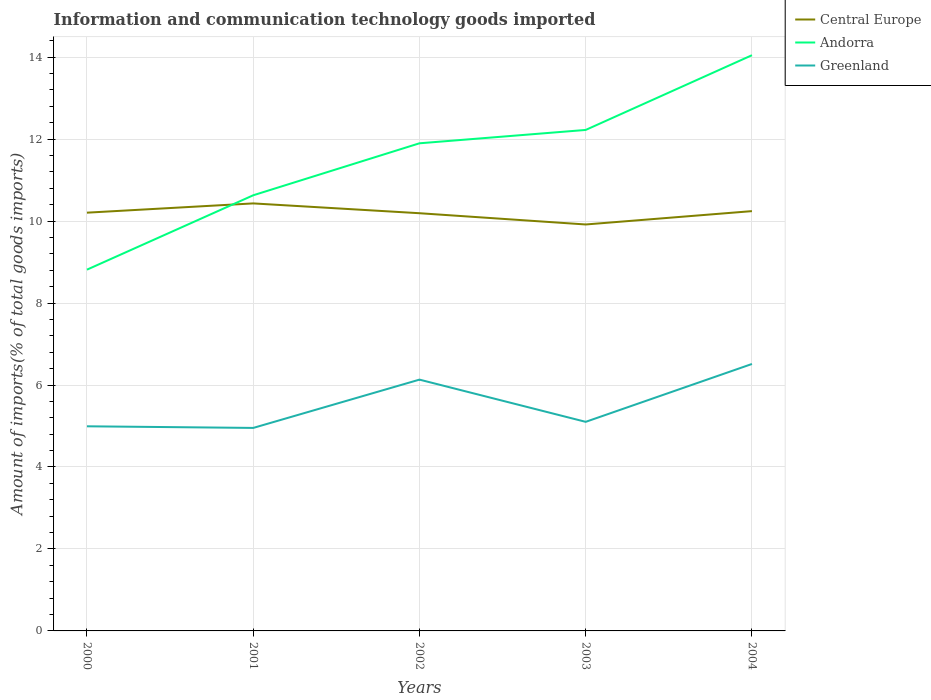Across all years, what is the maximum amount of goods imported in Greenland?
Keep it short and to the point. 4.95. What is the total amount of goods imported in Andorra in the graph?
Offer a terse response. -1.27. What is the difference between the highest and the second highest amount of goods imported in Andorra?
Offer a terse response. 5.23. What is the difference between the highest and the lowest amount of goods imported in Central Europe?
Offer a terse response. 3. Is the amount of goods imported in Andorra strictly greater than the amount of goods imported in Central Europe over the years?
Make the answer very short. No. Are the values on the major ticks of Y-axis written in scientific E-notation?
Ensure brevity in your answer.  No. Does the graph contain any zero values?
Your answer should be compact. No. Does the graph contain grids?
Keep it short and to the point. Yes. How many legend labels are there?
Provide a succinct answer. 3. How are the legend labels stacked?
Your response must be concise. Vertical. What is the title of the graph?
Give a very brief answer. Information and communication technology goods imported. What is the label or title of the X-axis?
Give a very brief answer. Years. What is the label or title of the Y-axis?
Make the answer very short. Amount of imports(% of total goods imports). What is the Amount of imports(% of total goods imports) in Central Europe in 2000?
Your answer should be very brief. 10.2. What is the Amount of imports(% of total goods imports) in Andorra in 2000?
Keep it short and to the point. 8.81. What is the Amount of imports(% of total goods imports) in Greenland in 2000?
Ensure brevity in your answer.  4.99. What is the Amount of imports(% of total goods imports) in Central Europe in 2001?
Offer a very short reply. 10.43. What is the Amount of imports(% of total goods imports) in Andorra in 2001?
Give a very brief answer. 10.63. What is the Amount of imports(% of total goods imports) of Greenland in 2001?
Provide a succinct answer. 4.95. What is the Amount of imports(% of total goods imports) in Central Europe in 2002?
Offer a very short reply. 10.19. What is the Amount of imports(% of total goods imports) in Andorra in 2002?
Ensure brevity in your answer.  11.9. What is the Amount of imports(% of total goods imports) in Greenland in 2002?
Provide a succinct answer. 6.13. What is the Amount of imports(% of total goods imports) of Central Europe in 2003?
Ensure brevity in your answer.  9.92. What is the Amount of imports(% of total goods imports) of Andorra in 2003?
Your answer should be compact. 12.22. What is the Amount of imports(% of total goods imports) in Greenland in 2003?
Offer a very short reply. 5.1. What is the Amount of imports(% of total goods imports) in Central Europe in 2004?
Your answer should be compact. 10.24. What is the Amount of imports(% of total goods imports) in Andorra in 2004?
Your answer should be compact. 14.05. What is the Amount of imports(% of total goods imports) in Greenland in 2004?
Make the answer very short. 6.51. Across all years, what is the maximum Amount of imports(% of total goods imports) in Central Europe?
Make the answer very short. 10.43. Across all years, what is the maximum Amount of imports(% of total goods imports) in Andorra?
Ensure brevity in your answer.  14.05. Across all years, what is the maximum Amount of imports(% of total goods imports) in Greenland?
Keep it short and to the point. 6.51. Across all years, what is the minimum Amount of imports(% of total goods imports) in Central Europe?
Offer a terse response. 9.92. Across all years, what is the minimum Amount of imports(% of total goods imports) of Andorra?
Provide a succinct answer. 8.81. Across all years, what is the minimum Amount of imports(% of total goods imports) of Greenland?
Provide a short and direct response. 4.95. What is the total Amount of imports(% of total goods imports) of Central Europe in the graph?
Give a very brief answer. 50.99. What is the total Amount of imports(% of total goods imports) in Andorra in the graph?
Make the answer very short. 57.61. What is the total Amount of imports(% of total goods imports) in Greenland in the graph?
Offer a terse response. 27.69. What is the difference between the Amount of imports(% of total goods imports) in Central Europe in 2000 and that in 2001?
Your answer should be very brief. -0.23. What is the difference between the Amount of imports(% of total goods imports) in Andorra in 2000 and that in 2001?
Your response must be concise. -1.81. What is the difference between the Amount of imports(% of total goods imports) in Greenland in 2000 and that in 2001?
Provide a short and direct response. 0.04. What is the difference between the Amount of imports(% of total goods imports) of Central Europe in 2000 and that in 2002?
Ensure brevity in your answer.  0.01. What is the difference between the Amount of imports(% of total goods imports) in Andorra in 2000 and that in 2002?
Your answer should be compact. -3.08. What is the difference between the Amount of imports(% of total goods imports) of Greenland in 2000 and that in 2002?
Give a very brief answer. -1.14. What is the difference between the Amount of imports(% of total goods imports) of Central Europe in 2000 and that in 2003?
Your answer should be compact. 0.29. What is the difference between the Amount of imports(% of total goods imports) of Andorra in 2000 and that in 2003?
Ensure brevity in your answer.  -3.41. What is the difference between the Amount of imports(% of total goods imports) of Greenland in 2000 and that in 2003?
Your answer should be very brief. -0.11. What is the difference between the Amount of imports(% of total goods imports) in Central Europe in 2000 and that in 2004?
Offer a terse response. -0.04. What is the difference between the Amount of imports(% of total goods imports) of Andorra in 2000 and that in 2004?
Provide a short and direct response. -5.23. What is the difference between the Amount of imports(% of total goods imports) of Greenland in 2000 and that in 2004?
Your answer should be compact. -1.52. What is the difference between the Amount of imports(% of total goods imports) in Central Europe in 2001 and that in 2002?
Give a very brief answer. 0.24. What is the difference between the Amount of imports(% of total goods imports) of Andorra in 2001 and that in 2002?
Keep it short and to the point. -1.27. What is the difference between the Amount of imports(% of total goods imports) of Greenland in 2001 and that in 2002?
Your response must be concise. -1.18. What is the difference between the Amount of imports(% of total goods imports) in Central Europe in 2001 and that in 2003?
Your answer should be very brief. 0.51. What is the difference between the Amount of imports(% of total goods imports) in Andorra in 2001 and that in 2003?
Make the answer very short. -1.59. What is the difference between the Amount of imports(% of total goods imports) of Greenland in 2001 and that in 2003?
Make the answer very short. -0.15. What is the difference between the Amount of imports(% of total goods imports) in Central Europe in 2001 and that in 2004?
Provide a succinct answer. 0.19. What is the difference between the Amount of imports(% of total goods imports) in Andorra in 2001 and that in 2004?
Your response must be concise. -3.42. What is the difference between the Amount of imports(% of total goods imports) in Greenland in 2001 and that in 2004?
Keep it short and to the point. -1.56. What is the difference between the Amount of imports(% of total goods imports) of Central Europe in 2002 and that in 2003?
Provide a succinct answer. 0.27. What is the difference between the Amount of imports(% of total goods imports) in Andorra in 2002 and that in 2003?
Offer a terse response. -0.33. What is the difference between the Amount of imports(% of total goods imports) in Greenland in 2002 and that in 2003?
Your response must be concise. 1.03. What is the difference between the Amount of imports(% of total goods imports) of Central Europe in 2002 and that in 2004?
Provide a succinct answer. -0.05. What is the difference between the Amount of imports(% of total goods imports) of Andorra in 2002 and that in 2004?
Make the answer very short. -2.15. What is the difference between the Amount of imports(% of total goods imports) in Greenland in 2002 and that in 2004?
Your answer should be very brief. -0.38. What is the difference between the Amount of imports(% of total goods imports) of Central Europe in 2003 and that in 2004?
Provide a short and direct response. -0.33. What is the difference between the Amount of imports(% of total goods imports) of Andorra in 2003 and that in 2004?
Make the answer very short. -1.82. What is the difference between the Amount of imports(% of total goods imports) of Greenland in 2003 and that in 2004?
Give a very brief answer. -1.41. What is the difference between the Amount of imports(% of total goods imports) of Central Europe in 2000 and the Amount of imports(% of total goods imports) of Andorra in 2001?
Offer a very short reply. -0.42. What is the difference between the Amount of imports(% of total goods imports) in Central Europe in 2000 and the Amount of imports(% of total goods imports) in Greenland in 2001?
Your answer should be very brief. 5.25. What is the difference between the Amount of imports(% of total goods imports) in Andorra in 2000 and the Amount of imports(% of total goods imports) in Greenland in 2001?
Provide a short and direct response. 3.86. What is the difference between the Amount of imports(% of total goods imports) of Central Europe in 2000 and the Amount of imports(% of total goods imports) of Andorra in 2002?
Give a very brief answer. -1.69. What is the difference between the Amount of imports(% of total goods imports) of Central Europe in 2000 and the Amount of imports(% of total goods imports) of Greenland in 2002?
Provide a short and direct response. 4.07. What is the difference between the Amount of imports(% of total goods imports) in Andorra in 2000 and the Amount of imports(% of total goods imports) in Greenland in 2002?
Your answer should be compact. 2.68. What is the difference between the Amount of imports(% of total goods imports) of Central Europe in 2000 and the Amount of imports(% of total goods imports) of Andorra in 2003?
Ensure brevity in your answer.  -2.02. What is the difference between the Amount of imports(% of total goods imports) in Central Europe in 2000 and the Amount of imports(% of total goods imports) in Greenland in 2003?
Give a very brief answer. 5.1. What is the difference between the Amount of imports(% of total goods imports) of Andorra in 2000 and the Amount of imports(% of total goods imports) of Greenland in 2003?
Keep it short and to the point. 3.71. What is the difference between the Amount of imports(% of total goods imports) of Central Europe in 2000 and the Amount of imports(% of total goods imports) of Andorra in 2004?
Ensure brevity in your answer.  -3.84. What is the difference between the Amount of imports(% of total goods imports) of Central Europe in 2000 and the Amount of imports(% of total goods imports) of Greenland in 2004?
Your answer should be very brief. 3.69. What is the difference between the Amount of imports(% of total goods imports) of Andorra in 2000 and the Amount of imports(% of total goods imports) of Greenland in 2004?
Keep it short and to the point. 2.3. What is the difference between the Amount of imports(% of total goods imports) in Central Europe in 2001 and the Amount of imports(% of total goods imports) in Andorra in 2002?
Provide a succinct answer. -1.47. What is the difference between the Amount of imports(% of total goods imports) in Central Europe in 2001 and the Amount of imports(% of total goods imports) in Greenland in 2002?
Offer a very short reply. 4.3. What is the difference between the Amount of imports(% of total goods imports) in Andorra in 2001 and the Amount of imports(% of total goods imports) in Greenland in 2002?
Provide a succinct answer. 4.5. What is the difference between the Amount of imports(% of total goods imports) in Central Europe in 2001 and the Amount of imports(% of total goods imports) in Andorra in 2003?
Make the answer very short. -1.79. What is the difference between the Amount of imports(% of total goods imports) of Central Europe in 2001 and the Amount of imports(% of total goods imports) of Greenland in 2003?
Your answer should be compact. 5.33. What is the difference between the Amount of imports(% of total goods imports) of Andorra in 2001 and the Amount of imports(% of total goods imports) of Greenland in 2003?
Make the answer very short. 5.53. What is the difference between the Amount of imports(% of total goods imports) in Central Europe in 2001 and the Amount of imports(% of total goods imports) in Andorra in 2004?
Give a very brief answer. -3.62. What is the difference between the Amount of imports(% of total goods imports) of Central Europe in 2001 and the Amount of imports(% of total goods imports) of Greenland in 2004?
Offer a very short reply. 3.92. What is the difference between the Amount of imports(% of total goods imports) of Andorra in 2001 and the Amount of imports(% of total goods imports) of Greenland in 2004?
Keep it short and to the point. 4.12. What is the difference between the Amount of imports(% of total goods imports) in Central Europe in 2002 and the Amount of imports(% of total goods imports) in Andorra in 2003?
Keep it short and to the point. -2.03. What is the difference between the Amount of imports(% of total goods imports) of Central Europe in 2002 and the Amount of imports(% of total goods imports) of Greenland in 2003?
Provide a succinct answer. 5.09. What is the difference between the Amount of imports(% of total goods imports) of Andorra in 2002 and the Amount of imports(% of total goods imports) of Greenland in 2003?
Offer a terse response. 6.8. What is the difference between the Amount of imports(% of total goods imports) of Central Europe in 2002 and the Amount of imports(% of total goods imports) of Andorra in 2004?
Make the answer very short. -3.86. What is the difference between the Amount of imports(% of total goods imports) in Central Europe in 2002 and the Amount of imports(% of total goods imports) in Greenland in 2004?
Your response must be concise. 3.68. What is the difference between the Amount of imports(% of total goods imports) of Andorra in 2002 and the Amount of imports(% of total goods imports) of Greenland in 2004?
Your answer should be very brief. 5.38. What is the difference between the Amount of imports(% of total goods imports) of Central Europe in 2003 and the Amount of imports(% of total goods imports) of Andorra in 2004?
Offer a terse response. -4.13. What is the difference between the Amount of imports(% of total goods imports) in Central Europe in 2003 and the Amount of imports(% of total goods imports) in Greenland in 2004?
Keep it short and to the point. 3.4. What is the difference between the Amount of imports(% of total goods imports) of Andorra in 2003 and the Amount of imports(% of total goods imports) of Greenland in 2004?
Offer a very short reply. 5.71. What is the average Amount of imports(% of total goods imports) in Central Europe per year?
Ensure brevity in your answer.  10.2. What is the average Amount of imports(% of total goods imports) in Andorra per year?
Provide a succinct answer. 11.52. What is the average Amount of imports(% of total goods imports) of Greenland per year?
Offer a very short reply. 5.54. In the year 2000, what is the difference between the Amount of imports(% of total goods imports) in Central Europe and Amount of imports(% of total goods imports) in Andorra?
Make the answer very short. 1.39. In the year 2000, what is the difference between the Amount of imports(% of total goods imports) in Central Europe and Amount of imports(% of total goods imports) in Greenland?
Your answer should be very brief. 5.21. In the year 2000, what is the difference between the Amount of imports(% of total goods imports) in Andorra and Amount of imports(% of total goods imports) in Greenland?
Provide a short and direct response. 3.82. In the year 2001, what is the difference between the Amount of imports(% of total goods imports) in Central Europe and Amount of imports(% of total goods imports) in Andorra?
Your answer should be very brief. -0.2. In the year 2001, what is the difference between the Amount of imports(% of total goods imports) in Central Europe and Amount of imports(% of total goods imports) in Greenland?
Make the answer very short. 5.48. In the year 2001, what is the difference between the Amount of imports(% of total goods imports) of Andorra and Amount of imports(% of total goods imports) of Greenland?
Your response must be concise. 5.68. In the year 2002, what is the difference between the Amount of imports(% of total goods imports) in Central Europe and Amount of imports(% of total goods imports) in Andorra?
Provide a succinct answer. -1.71. In the year 2002, what is the difference between the Amount of imports(% of total goods imports) in Central Europe and Amount of imports(% of total goods imports) in Greenland?
Your response must be concise. 4.06. In the year 2002, what is the difference between the Amount of imports(% of total goods imports) in Andorra and Amount of imports(% of total goods imports) in Greenland?
Keep it short and to the point. 5.77. In the year 2003, what is the difference between the Amount of imports(% of total goods imports) in Central Europe and Amount of imports(% of total goods imports) in Andorra?
Your answer should be very brief. -2.31. In the year 2003, what is the difference between the Amount of imports(% of total goods imports) of Central Europe and Amount of imports(% of total goods imports) of Greenland?
Provide a succinct answer. 4.82. In the year 2003, what is the difference between the Amount of imports(% of total goods imports) of Andorra and Amount of imports(% of total goods imports) of Greenland?
Your response must be concise. 7.12. In the year 2004, what is the difference between the Amount of imports(% of total goods imports) in Central Europe and Amount of imports(% of total goods imports) in Andorra?
Your answer should be compact. -3.8. In the year 2004, what is the difference between the Amount of imports(% of total goods imports) of Central Europe and Amount of imports(% of total goods imports) of Greenland?
Your answer should be very brief. 3.73. In the year 2004, what is the difference between the Amount of imports(% of total goods imports) in Andorra and Amount of imports(% of total goods imports) in Greenland?
Provide a short and direct response. 7.53. What is the ratio of the Amount of imports(% of total goods imports) in Central Europe in 2000 to that in 2001?
Offer a terse response. 0.98. What is the ratio of the Amount of imports(% of total goods imports) in Andorra in 2000 to that in 2001?
Provide a short and direct response. 0.83. What is the ratio of the Amount of imports(% of total goods imports) in Greenland in 2000 to that in 2001?
Your answer should be very brief. 1.01. What is the ratio of the Amount of imports(% of total goods imports) of Central Europe in 2000 to that in 2002?
Your answer should be compact. 1. What is the ratio of the Amount of imports(% of total goods imports) in Andorra in 2000 to that in 2002?
Your response must be concise. 0.74. What is the ratio of the Amount of imports(% of total goods imports) in Greenland in 2000 to that in 2002?
Your response must be concise. 0.81. What is the ratio of the Amount of imports(% of total goods imports) in Andorra in 2000 to that in 2003?
Make the answer very short. 0.72. What is the ratio of the Amount of imports(% of total goods imports) in Greenland in 2000 to that in 2003?
Ensure brevity in your answer.  0.98. What is the ratio of the Amount of imports(% of total goods imports) in Central Europe in 2000 to that in 2004?
Offer a very short reply. 1. What is the ratio of the Amount of imports(% of total goods imports) of Andorra in 2000 to that in 2004?
Your answer should be very brief. 0.63. What is the ratio of the Amount of imports(% of total goods imports) in Greenland in 2000 to that in 2004?
Offer a terse response. 0.77. What is the ratio of the Amount of imports(% of total goods imports) in Central Europe in 2001 to that in 2002?
Offer a very short reply. 1.02. What is the ratio of the Amount of imports(% of total goods imports) of Andorra in 2001 to that in 2002?
Provide a succinct answer. 0.89. What is the ratio of the Amount of imports(% of total goods imports) of Greenland in 2001 to that in 2002?
Give a very brief answer. 0.81. What is the ratio of the Amount of imports(% of total goods imports) in Central Europe in 2001 to that in 2003?
Ensure brevity in your answer.  1.05. What is the ratio of the Amount of imports(% of total goods imports) in Andorra in 2001 to that in 2003?
Your answer should be compact. 0.87. What is the ratio of the Amount of imports(% of total goods imports) of Greenland in 2001 to that in 2003?
Your answer should be compact. 0.97. What is the ratio of the Amount of imports(% of total goods imports) in Central Europe in 2001 to that in 2004?
Offer a very short reply. 1.02. What is the ratio of the Amount of imports(% of total goods imports) of Andorra in 2001 to that in 2004?
Offer a terse response. 0.76. What is the ratio of the Amount of imports(% of total goods imports) in Greenland in 2001 to that in 2004?
Provide a succinct answer. 0.76. What is the ratio of the Amount of imports(% of total goods imports) in Central Europe in 2002 to that in 2003?
Make the answer very short. 1.03. What is the ratio of the Amount of imports(% of total goods imports) in Andorra in 2002 to that in 2003?
Offer a very short reply. 0.97. What is the ratio of the Amount of imports(% of total goods imports) of Greenland in 2002 to that in 2003?
Keep it short and to the point. 1.2. What is the ratio of the Amount of imports(% of total goods imports) in Central Europe in 2002 to that in 2004?
Provide a succinct answer. 0.99. What is the ratio of the Amount of imports(% of total goods imports) of Andorra in 2002 to that in 2004?
Offer a very short reply. 0.85. What is the ratio of the Amount of imports(% of total goods imports) of Greenland in 2002 to that in 2004?
Offer a very short reply. 0.94. What is the ratio of the Amount of imports(% of total goods imports) of Central Europe in 2003 to that in 2004?
Offer a terse response. 0.97. What is the ratio of the Amount of imports(% of total goods imports) in Andorra in 2003 to that in 2004?
Ensure brevity in your answer.  0.87. What is the ratio of the Amount of imports(% of total goods imports) of Greenland in 2003 to that in 2004?
Offer a terse response. 0.78. What is the difference between the highest and the second highest Amount of imports(% of total goods imports) of Central Europe?
Your response must be concise. 0.19. What is the difference between the highest and the second highest Amount of imports(% of total goods imports) in Andorra?
Make the answer very short. 1.82. What is the difference between the highest and the second highest Amount of imports(% of total goods imports) in Greenland?
Your answer should be compact. 0.38. What is the difference between the highest and the lowest Amount of imports(% of total goods imports) in Central Europe?
Your response must be concise. 0.51. What is the difference between the highest and the lowest Amount of imports(% of total goods imports) in Andorra?
Your response must be concise. 5.23. What is the difference between the highest and the lowest Amount of imports(% of total goods imports) in Greenland?
Offer a terse response. 1.56. 